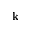Convert formula to latex. <formula><loc_0><loc_0><loc_500><loc_500>k</formula> 